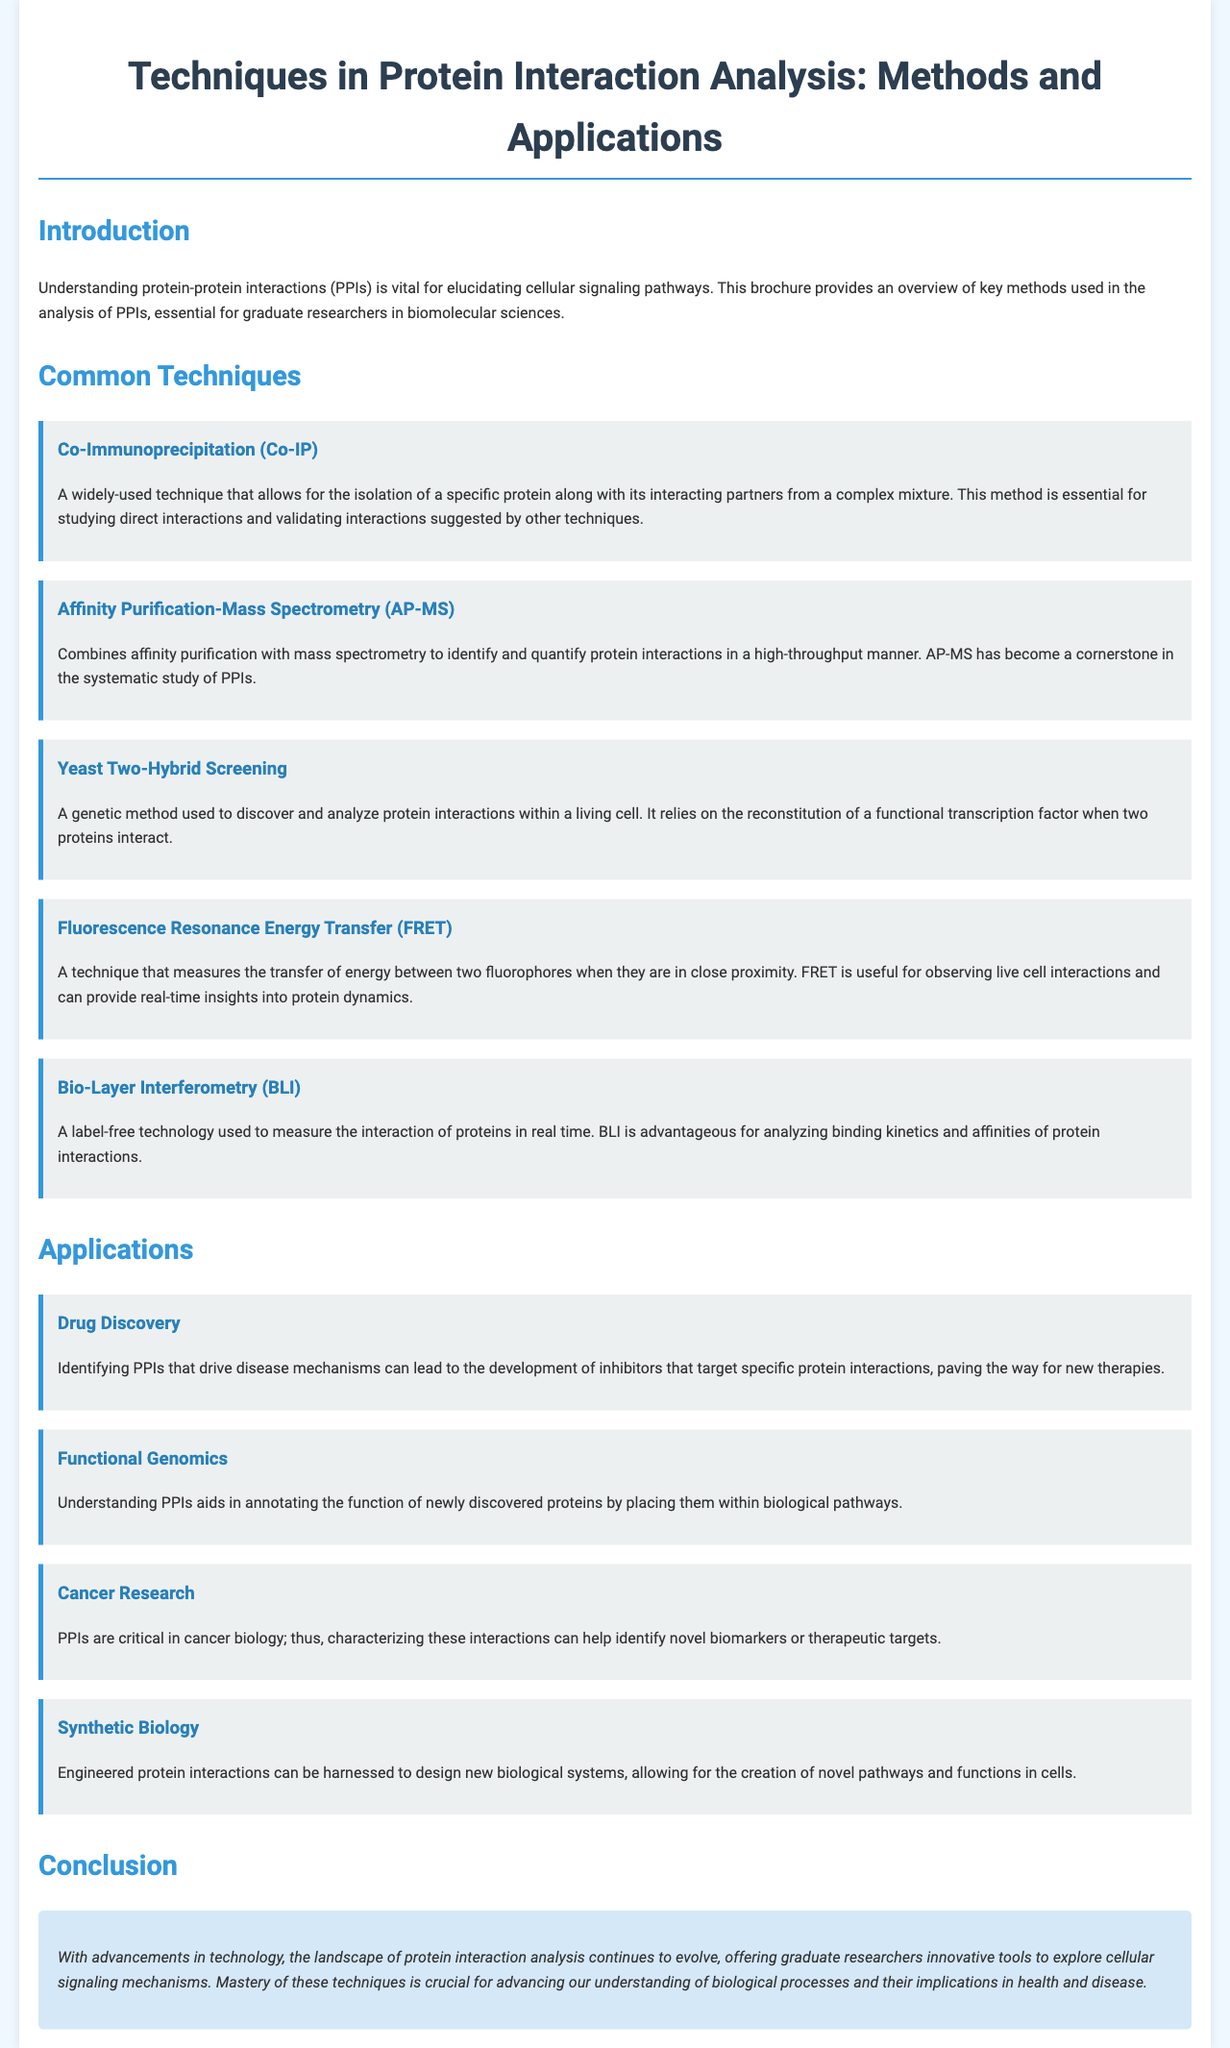What is the title of the brochure? The title is presented at the top of the document as the main heading.
Answer: Techniques in Protein Interaction Analysis: Methods and Applications What technique is used for isolating a specific protein? This information is found in the section about common techniques, specifically mentioning a popular method for this purpose.
Answer: Co-Immunoprecipitation (Co-IP) Which method combines affinity purification with mass spectrometry? The document outlines several techniques, and this method is specifically highlighted for its combination approach.
Answer: Affinity Purification-Mass Spectrometry (AP-MS) How many applications related to protein interactions are mentioned? This can be determined by counting the distinct applications listed in the applications section of the brochure.
Answer: Four What cellular component's interactions does the brochure primarily focus on? The introduction section establishes the main subject of the document right away.
Answer: Proteins Which technique is useful for observing live cell interactions? A specific technique is described that provides insights into protein dynamics in living cells.
Answer: Fluorescence Resonance Energy Transfer (FRET) What is a critical area of study highlighted in the applications section? One of the applications specifically focuses on a health-related field and its relevance to protein interactions.
Answer: Cancer Research What is the conclusion about the evolution of protein interaction analysis? The conclusion section summarizes the overall advancements discussed throughout the document.
Answer: Offers innovative tools Which technique involves measuring interaction in real time? The brochure specifies a technique that uses label-free technology for real-time measurements of interactions.
Answer: Bio-Layer Interferometry (BLI) 